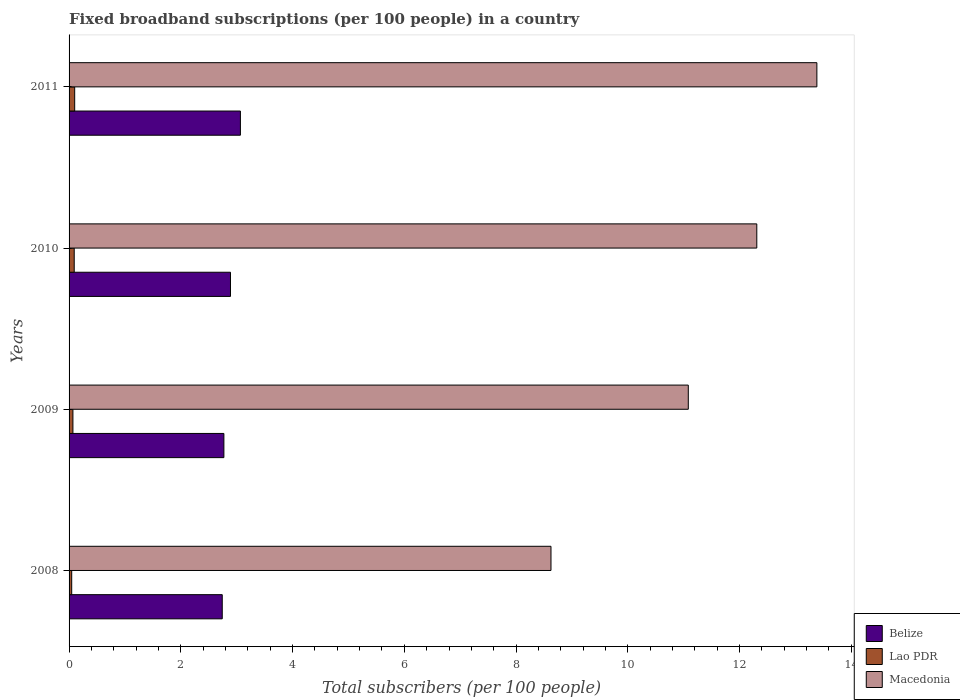How many different coloured bars are there?
Give a very brief answer. 3. Are the number of bars on each tick of the Y-axis equal?
Make the answer very short. Yes. How many bars are there on the 2nd tick from the top?
Give a very brief answer. 3. How many bars are there on the 3rd tick from the bottom?
Ensure brevity in your answer.  3. In how many cases, is the number of bars for a given year not equal to the number of legend labels?
Your answer should be very brief. 0. What is the number of broadband subscriptions in Macedonia in 2011?
Provide a succinct answer. 13.38. Across all years, what is the maximum number of broadband subscriptions in Macedonia?
Ensure brevity in your answer.  13.38. Across all years, what is the minimum number of broadband subscriptions in Lao PDR?
Provide a short and direct response. 0.05. What is the total number of broadband subscriptions in Macedonia in the graph?
Make the answer very short. 45.4. What is the difference between the number of broadband subscriptions in Macedonia in 2008 and that in 2011?
Your answer should be compact. -4.76. What is the difference between the number of broadband subscriptions in Lao PDR in 2011 and the number of broadband subscriptions in Macedonia in 2008?
Provide a succinct answer. -8.52. What is the average number of broadband subscriptions in Belize per year?
Give a very brief answer. 2.87. In the year 2008, what is the difference between the number of broadband subscriptions in Belize and number of broadband subscriptions in Macedonia?
Provide a short and direct response. -5.88. In how many years, is the number of broadband subscriptions in Macedonia greater than 10 ?
Provide a succinct answer. 3. What is the ratio of the number of broadband subscriptions in Belize in 2008 to that in 2009?
Make the answer very short. 0.99. What is the difference between the highest and the second highest number of broadband subscriptions in Belize?
Your response must be concise. 0.18. What is the difference between the highest and the lowest number of broadband subscriptions in Macedonia?
Provide a succinct answer. 4.76. In how many years, is the number of broadband subscriptions in Belize greater than the average number of broadband subscriptions in Belize taken over all years?
Provide a succinct answer. 2. What does the 3rd bar from the top in 2010 represents?
Provide a short and direct response. Belize. What does the 1st bar from the bottom in 2011 represents?
Your answer should be compact. Belize. What is the difference between two consecutive major ticks on the X-axis?
Your answer should be very brief. 2. Are the values on the major ticks of X-axis written in scientific E-notation?
Offer a terse response. No. What is the title of the graph?
Provide a succinct answer. Fixed broadband subscriptions (per 100 people) in a country. What is the label or title of the X-axis?
Give a very brief answer. Total subscribers (per 100 people). What is the label or title of the Y-axis?
Offer a very short reply. Years. What is the Total subscribers (per 100 people) of Belize in 2008?
Provide a short and direct response. 2.74. What is the Total subscribers (per 100 people) of Lao PDR in 2008?
Give a very brief answer. 0.05. What is the Total subscribers (per 100 people) of Macedonia in 2008?
Offer a very short reply. 8.62. What is the Total subscribers (per 100 people) of Belize in 2009?
Offer a very short reply. 2.77. What is the Total subscribers (per 100 people) in Lao PDR in 2009?
Your answer should be compact. 0.07. What is the Total subscribers (per 100 people) in Macedonia in 2009?
Your response must be concise. 11.08. What is the Total subscribers (per 100 people) of Belize in 2010?
Make the answer very short. 2.89. What is the Total subscribers (per 100 people) in Lao PDR in 2010?
Provide a succinct answer. 0.09. What is the Total subscribers (per 100 people) in Macedonia in 2010?
Ensure brevity in your answer.  12.31. What is the Total subscribers (per 100 people) in Belize in 2011?
Your answer should be very brief. 3.07. What is the Total subscribers (per 100 people) in Lao PDR in 2011?
Your response must be concise. 0.1. What is the Total subscribers (per 100 people) of Macedonia in 2011?
Your answer should be very brief. 13.38. Across all years, what is the maximum Total subscribers (per 100 people) of Belize?
Keep it short and to the point. 3.07. Across all years, what is the maximum Total subscribers (per 100 people) of Lao PDR?
Make the answer very short. 0.1. Across all years, what is the maximum Total subscribers (per 100 people) of Macedonia?
Ensure brevity in your answer.  13.38. Across all years, what is the minimum Total subscribers (per 100 people) of Belize?
Give a very brief answer. 2.74. Across all years, what is the minimum Total subscribers (per 100 people) of Lao PDR?
Give a very brief answer. 0.05. Across all years, what is the minimum Total subscribers (per 100 people) of Macedonia?
Ensure brevity in your answer.  8.62. What is the total Total subscribers (per 100 people) in Belize in the graph?
Ensure brevity in your answer.  11.47. What is the total Total subscribers (per 100 people) of Lao PDR in the graph?
Your answer should be compact. 0.31. What is the total Total subscribers (per 100 people) of Macedonia in the graph?
Keep it short and to the point. 45.4. What is the difference between the Total subscribers (per 100 people) of Belize in 2008 and that in 2009?
Your answer should be very brief. -0.03. What is the difference between the Total subscribers (per 100 people) of Lao PDR in 2008 and that in 2009?
Keep it short and to the point. -0.02. What is the difference between the Total subscribers (per 100 people) of Macedonia in 2008 and that in 2009?
Keep it short and to the point. -2.46. What is the difference between the Total subscribers (per 100 people) in Belize in 2008 and that in 2010?
Your response must be concise. -0.15. What is the difference between the Total subscribers (per 100 people) in Lao PDR in 2008 and that in 2010?
Your answer should be very brief. -0.04. What is the difference between the Total subscribers (per 100 people) in Macedonia in 2008 and that in 2010?
Keep it short and to the point. -3.68. What is the difference between the Total subscribers (per 100 people) in Belize in 2008 and that in 2011?
Offer a terse response. -0.32. What is the difference between the Total subscribers (per 100 people) in Lao PDR in 2008 and that in 2011?
Give a very brief answer. -0.05. What is the difference between the Total subscribers (per 100 people) of Macedonia in 2008 and that in 2011?
Offer a very short reply. -4.76. What is the difference between the Total subscribers (per 100 people) in Belize in 2009 and that in 2010?
Provide a short and direct response. -0.12. What is the difference between the Total subscribers (per 100 people) in Lao PDR in 2009 and that in 2010?
Offer a very short reply. -0.02. What is the difference between the Total subscribers (per 100 people) of Macedonia in 2009 and that in 2010?
Offer a very short reply. -1.23. What is the difference between the Total subscribers (per 100 people) of Belize in 2009 and that in 2011?
Offer a very short reply. -0.3. What is the difference between the Total subscribers (per 100 people) of Lao PDR in 2009 and that in 2011?
Your response must be concise. -0.03. What is the difference between the Total subscribers (per 100 people) of Macedonia in 2009 and that in 2011?
Your response must be concise. -2.3. What is the difference between the Total subscribers (per 100 people) of Belize in 2010 and that in 2011?
Offer a very short reply. -0.18. What is the difference between the Total subscribers (per 100 people) of Lao PDR in 2010 and that in 2011?
Your answer should be compact. -0.01. What is the difference between the Total subscribers (per 100 people) of Macedonia in 2010 and that in 2011?
Offer a very short reply. -1.08. What is the difference between the Total subscribers (per 100 people) of Belize in 2008 and the Total subscribers (per 100 people) of Lao PDR in 2009?
Keep it short and to the point. 2.67. What is the difference between the Total subscribers (per 100 people) in Belize in 2008 and the Total subscribers (per 100 people) in Macedonia in 2009?
Offer a terse response. -8.34. What is the difference between the Total subscribers (per 100 people) of Lao PDR in 2008 and the Total subscribers (per 100 people) of Macedonia in 2009?
Provide a short and direct response. -11.03. What is the difference between the Total subscribers (per 100 people) in Belize in 2008 and the Total subscribers (per 100 people) in Lao PDR in 2010?
Provide a succinct answer. 2.65. What is the difference between the Total subscribers (per 100 people) in Belize in 2008 and the Total subscribers (per 100 people) in Macedonia in 2010?
Offer a very short reply. -9.57. What is the difference between the Total subscribers (per 100 people) of Lao PDR in 2008 and the Total subscribers (per 100 people) of Macedonia in 2010?
Make the answer very short. -12.26. What is the difference between the Total subscribers (per 100 people) of Belize in 2008 and the Total subscribers (per 100 people) of Lao PDR in 2011?
Offer a terse response. 2.64. What is the difference between the Total subscribers (per 100 people) in Belize in 2008 and the Total subscribers (per 100 people) in Macedonia in 2011?
Ensure brevity in your answer.  -10.64. What is the difference between the Total subscribers (per 100 people) in Lao PDR in 2008 and the Total subscribers (per 100 people) in Macedonia in 2011?
Give a very brief answer. -13.34. What is the difference between the Total subscribers (per 100 people) of Belize in 2009 and the Total subscribers (per 100 people) of Lao PDR in 2010?
Keep it short and to the point. 2.68. What is the difference between the Total subscribers (per 100 people) in Belize in 2009 and the Total subscribers (per 100 people) in Macedonia in 2010?
Ensure brevity in your answer.  -9.54. What is the difference between the Total subscribers (per 100 people) of Lao PDR in 2009 and the Total subscribers (per 100 people) of Macedonia in 2010?
Provide a short and direct response. -12.24. What is the difference between the Total subscribers (per 100 people) in Belize in 2009 and the Total subscribers (per 100 people) in Lao PDR in 2011?
Give a very brief answer. 2.67. What is the difference between the Total subscribers (per 100 people) in Belize in 2009 and the Total subscribers (per 100 people) in Macedonia in 2011?
Provide a short and direct response. -10.61. What is the difference between the Total subscribers (per 100 people) in Lao PDR in 2009 and the Total subscribers (per 100 people) in Macedonia in 2011?
Provide a succinct answer. -13.31. What is the difference between the Total subscribers (per 100 people) of Belize in 2010 and the Total subscribers (per 100 people) of Lao PDR in 2011?
Your answer should be very brief. 2.79. What is the difference between the Total subscribers (per 100 people) in Belize in 2010 and the Total subscribers (per 100 people) in Macedonia in 2011?
Offer a terse response. -10.49. What is the difference between the Total subscribers (per 100 people) of Lao PDR in 2010 and the Total subscribers (per 100 people) of Macedonia in 2011?
Provide a short and direct response. -13.29. What is the average Total subscribers (per 100 people) of Belize per year?
Ensure brevity in your answer.  2.87. What is the average Total subscribers (per 100 people) of Lao PDR per year?
Give a very brief answer. 0.08. What is the average Total subscribers (per 100 people) in Macedonia per year?
Give a very brief answer. 11.35. In the year 2008, what is the difference between the Total subscribers (per 100 people) of Belize and Total subscribers (per 100 people) of Lao PDR?
Offer a very short reply. 2.69. In the year 2008, what is the difference between the Total subscribers (per 100 people) in Belize and Total subscribers (per 100 people) in Macedonia?
Your response must be concise. -5.88. In the year 2008, what is the difference between the Total subscribers (per 100 people) of Lao PDR and Total subscribers (per 100 people) of Macedonia?
Your response must be concise. -8.58. In the year 2009, what is the difference between the Total subscribers (per 100 people) in Belize and Total subscribers (per 100 people) in Lao PDR?
Make the answer very short. 2.7. In the year 2009, what is the difference between the Total subscribers (per 100 people) in Belize and Total subscribers (per 100 people) in Macedonia?
Your answer should be very brief. -8.31. In the year 2009, what is the difference between the Total subscribers (per 100 people) of Lao PDR and Total subscribers (per 100 people) of Macedonia?
Your answer should be very brief. -11.01. In the year 2010, what is the difference between the Total subscribers (per 100 people) in Belize and Total subscribers (per 100 people) in Lao PDR?
Your answer should be very brief. 2.8. In the year 2010, what is the difference between the Total subscribers (per 100 people) in Belize and Total subscribers (per 100 people) in Macedonia?
Your response must be concise. -9.42. In the year 2010, what is the difference between the Total subscribers (per 100 people) in Lao PDR and Total subscribers (per 100 people) in Macedonia?
Your answer should be very brief. -12.22. In the year 2011, what is the difference between the Total subscribers (per 100 people) in Belize and Total subscribers (per 100 people) in Lao PDR?
Offer a very short reply. 2.97. In the year 2011, what is the difference between the Total subscribers (per 100 people) in Belize and Total subscribers (per 100 people) in Macedonia?
Ensure brevity in your answer.  -10.32. In the year 2011, what is the difference between the Total subscribers (per 100 people) of Lao PDR and Total subscribers (per 100 people) of Macedonia?
Your answer should be very brief. -13.28. What is the ratio of the Total subscribers (per 100 people) in Belize in 2008 to that in 2009?
Offer a very short reply. 0.99. What is the ratio of the Total subscribers (per 100 people) in Lao PDR in 2008 to that in 2009?
Keep it short and to the point. 0.68. What is the ratio of the Total subscribers (per 100 people) in Macedonia in 2008 to that in 2009?
Your answer should be very brief. 0.78. What is the ratio of the Total subscribers (per 100 people) in Belize in 2008 to that in 2010?
Your answer should be compact. 0.95. What is the ratio of the Total subscribers (per 100 people) in Lao PDR in 2008 to that in 2010?
Make the answer very short. 0.51. What is the ratio of the Total subscribers (per 100 people) in Macedonia in 2008 to that in 2010?
Your answer should be compact. 0.7. What is the ratio of the Total subscribers (per 100 people) in Belize in 2008 to that in 2011?
Make the answer very short. 0.89. What is the ratio of the Total subscribers (per 100 people) in Lao PDR in 2008 to that in 2011?
Give a very brief answer. 0.47. What is the ratio of the Total subscribers (per 100 people) in Macedonia in 2008 to that in 2011?
Your answer should be very brief. 0.64. What is the ratio of the Total subscribers (per 100 people) in Belize in 2009 to that in 2010?
Give a very brief answer. 0.96. What is the ratio of the Total subscribers (per 100 people) in Lao PDR in 2009 to that in 2010?
Provide a succinct answer. 0.75. What is the ratio of the Total subscribers (per 100 people) of Macedonia in 2009 to that in 2010?
Offer a terse response. 0.9. What is the ratio of the Total subscribers (per 100 people) in Belize in 2009 to that in 2011?
Your response must be concise. 0.9. What is the ratio of the Total subscribers (per 100 people) of Lao PDR in 2009 to that in 2011?
Ensure brevity in your answer.  0.69. What is the ratio of the Total subscribers (per 100 people) in Macedonia in 2009 to that in 2011?
Your answer should be compact. 0.83. What is the ratio of the Total subscribers (per 100 people) in Belize in 2010 to that in 2011?
Keep it short and to the point. 0.94. What is the ratio of the Total subscribers (per 100 people) in Lao PDR in 2010 to that in 2011?
Keep it short and to the point. 0.92. What is the ratio of the Total subscribers (per 100 people) in Macedonia in 2010 to that in 2011?
Give a very brief answer. 0.92. What is the difference between the highest and the second highest Total subscribers (per 100 people) of Belize?
Provide a succinct answer. 0.18. What is the difference between the highest and the second highest Total subscribers (per 100 people) in Lao PDR?
Your answer should be compact. 0.01. What is the difference between the highest and the second highest Total subscribers (per 100 people) in Macedonia?
Give a very brief answer. 1.08. What is the difference between the highest and the lowest Total subscribers (per 100 people) of Belize?
Ensure brevity in your answer.  0.32. What is the difference between the highest and the lowest Total subscribers (per 100 people) in Lao PDR?
Provide a short and direct response. 0.05. What is the difference between the highest and the lowest Total subscribers (per 100 people) of Macedonia?
Make the answer very short. 4.76. 